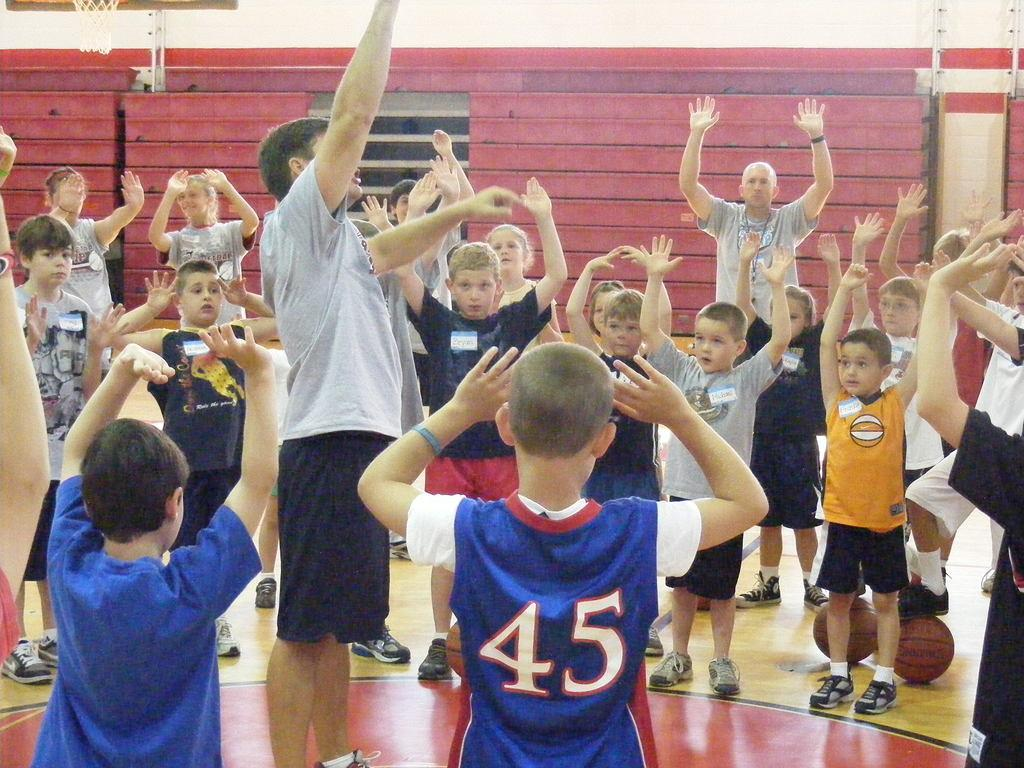How many children are in the image? There are kids in the image, but the exact number is not specified. How many adults are in the image? There are two adults in the image. What are the kids and adults doing in the image? The kids and adults are raising their hands up in the air. What objects related to basketball can be seen on the floor? There are two basketballs on the floor. What can be seen in the background of the image? There is a wall and a net of a basketball hoop in the background of the image. What type of art is displayed on the wall in the image? There is no art displayed on the wall in the image; it is a plain wall with a basketball hoop net in the background. What year does the image depict? The image does not provide any information about the year it depicts. 